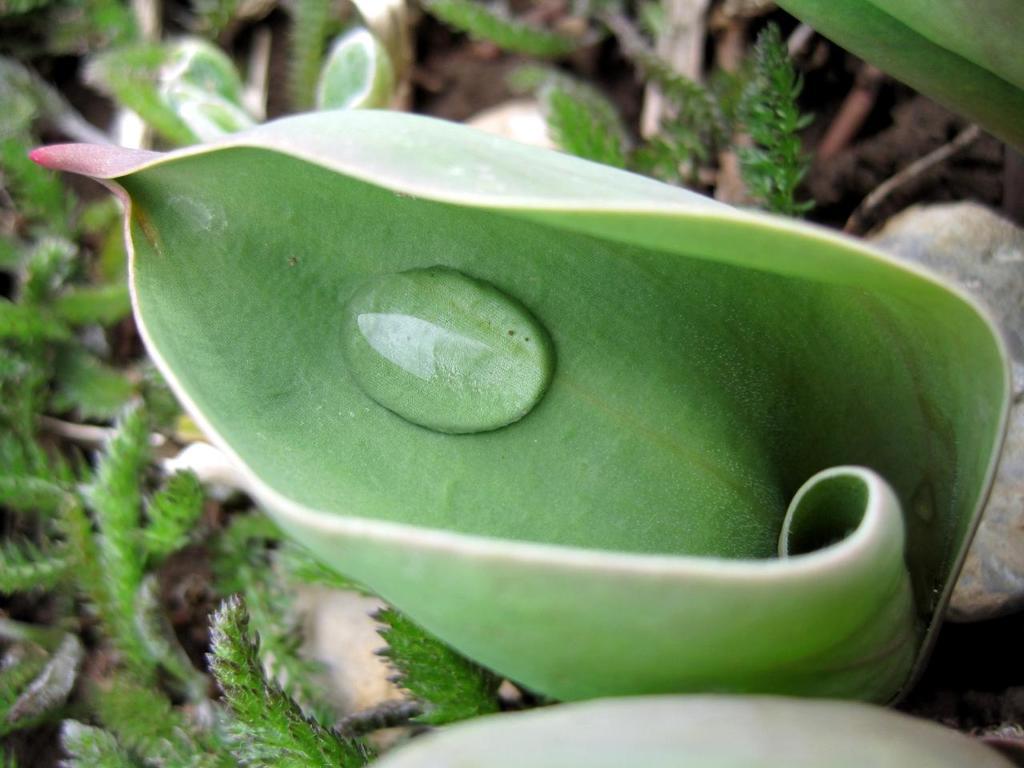How would you summarize this image in a sentence or two? In the center of the image there is a leaf and we can see a water drop on it. In the background there are plants. 